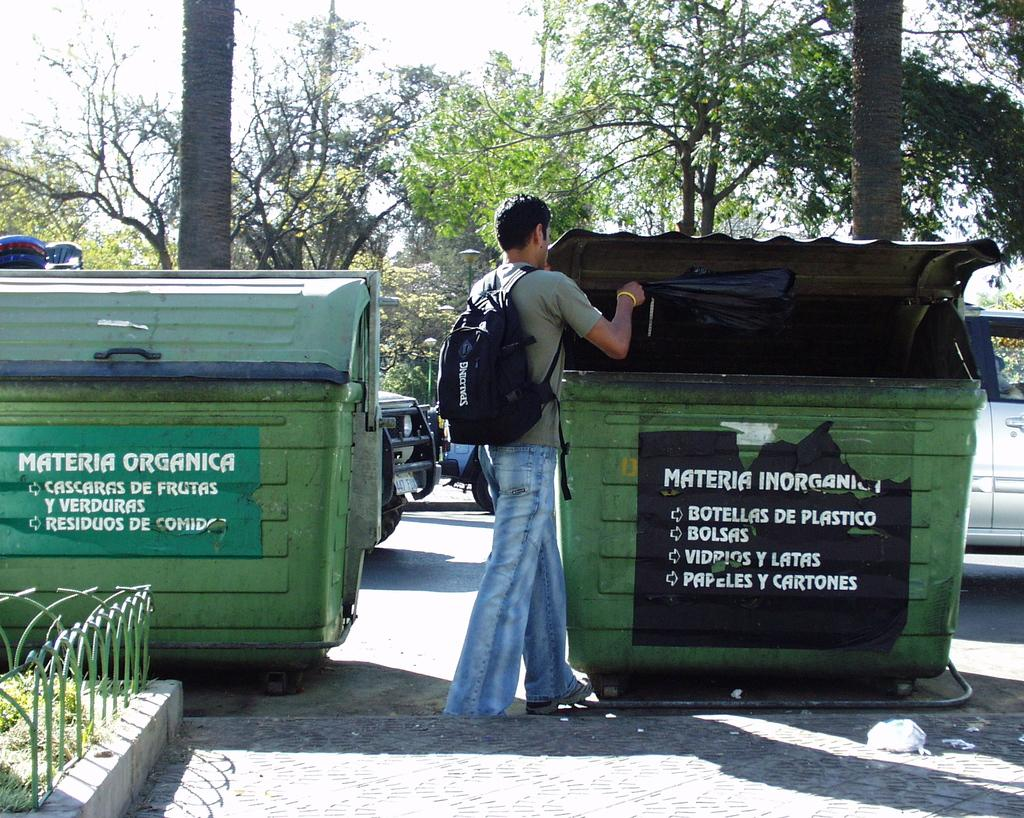<image>
Give a short and clear explanation of the subsequent image. A man wearing a backpack putting a black bag of items into a dumpster that reads "Materia Inorganic". 